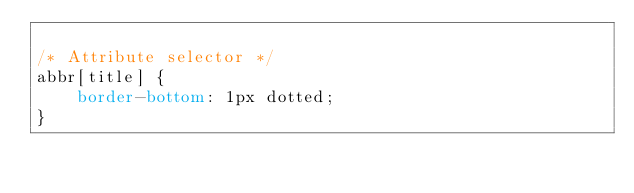<code> <loc_0><loc_0><loc_500><loc_500><_CSS_>
/* Attribute selector */
abbr[title] {
    border-bottom: 1px dotted;
}
</code> 